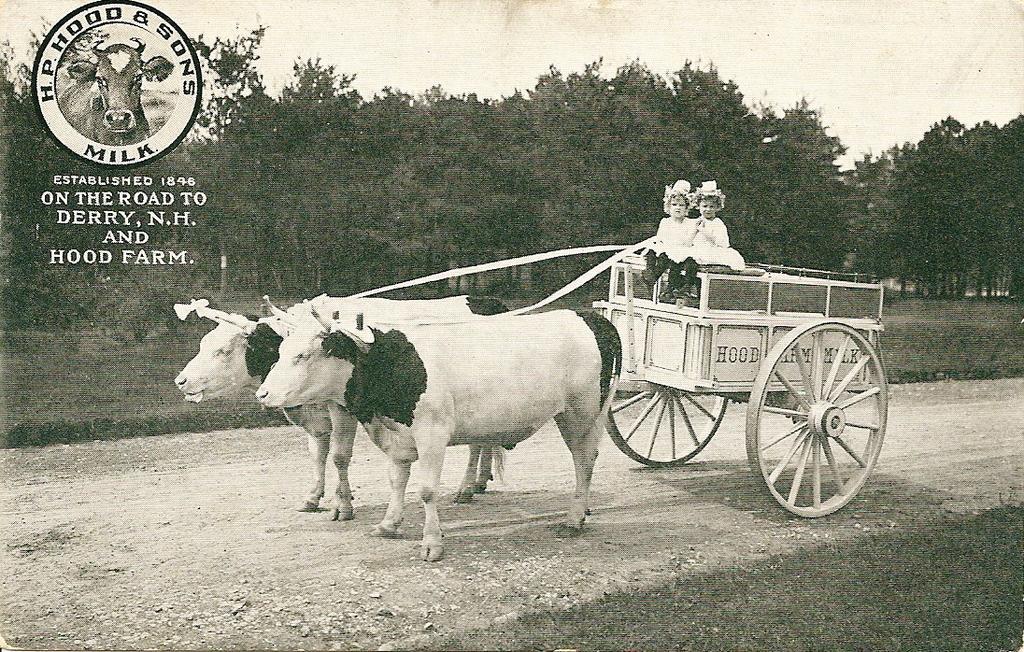In one or two sentences, can you explain what this image depicts? In this image I can see the bullock cart with some text written on it. I can see two kids. In the background, I can see the trees. In the top left corner, I can also see some text written on it. I can also see the image is in black and white color. 